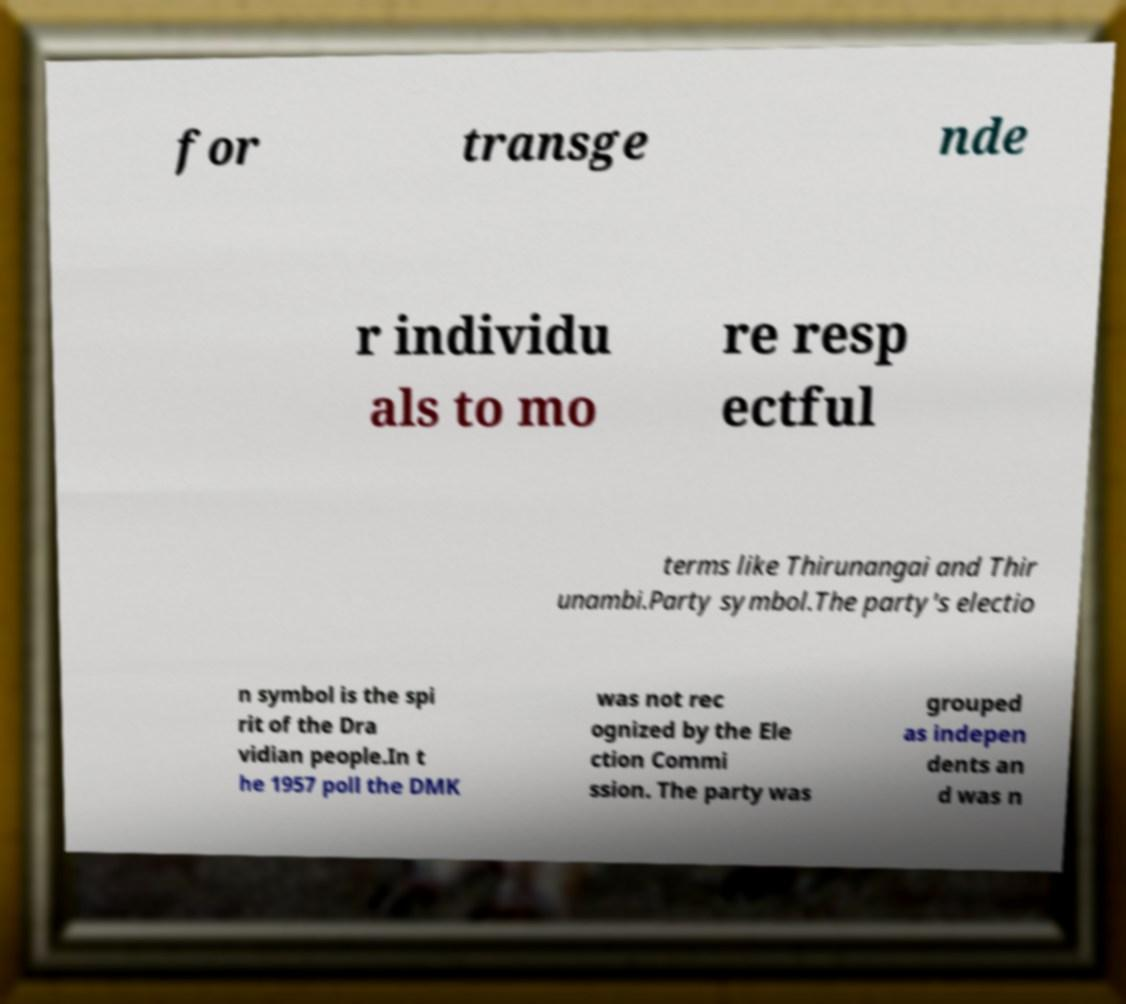Can you accurately transcribe the text from the provided image for me? for transge nde r individu als to mo re resp ectful terms like Thirunangai and Thir unambi.Party symbol.The party's electio n symbol is the spi rit of the Dra vidian people.In t he 1957 poll the DMK was not rec ognized by the Ele ction Commi ssion. The party was grouped as indepen dents an d was n 